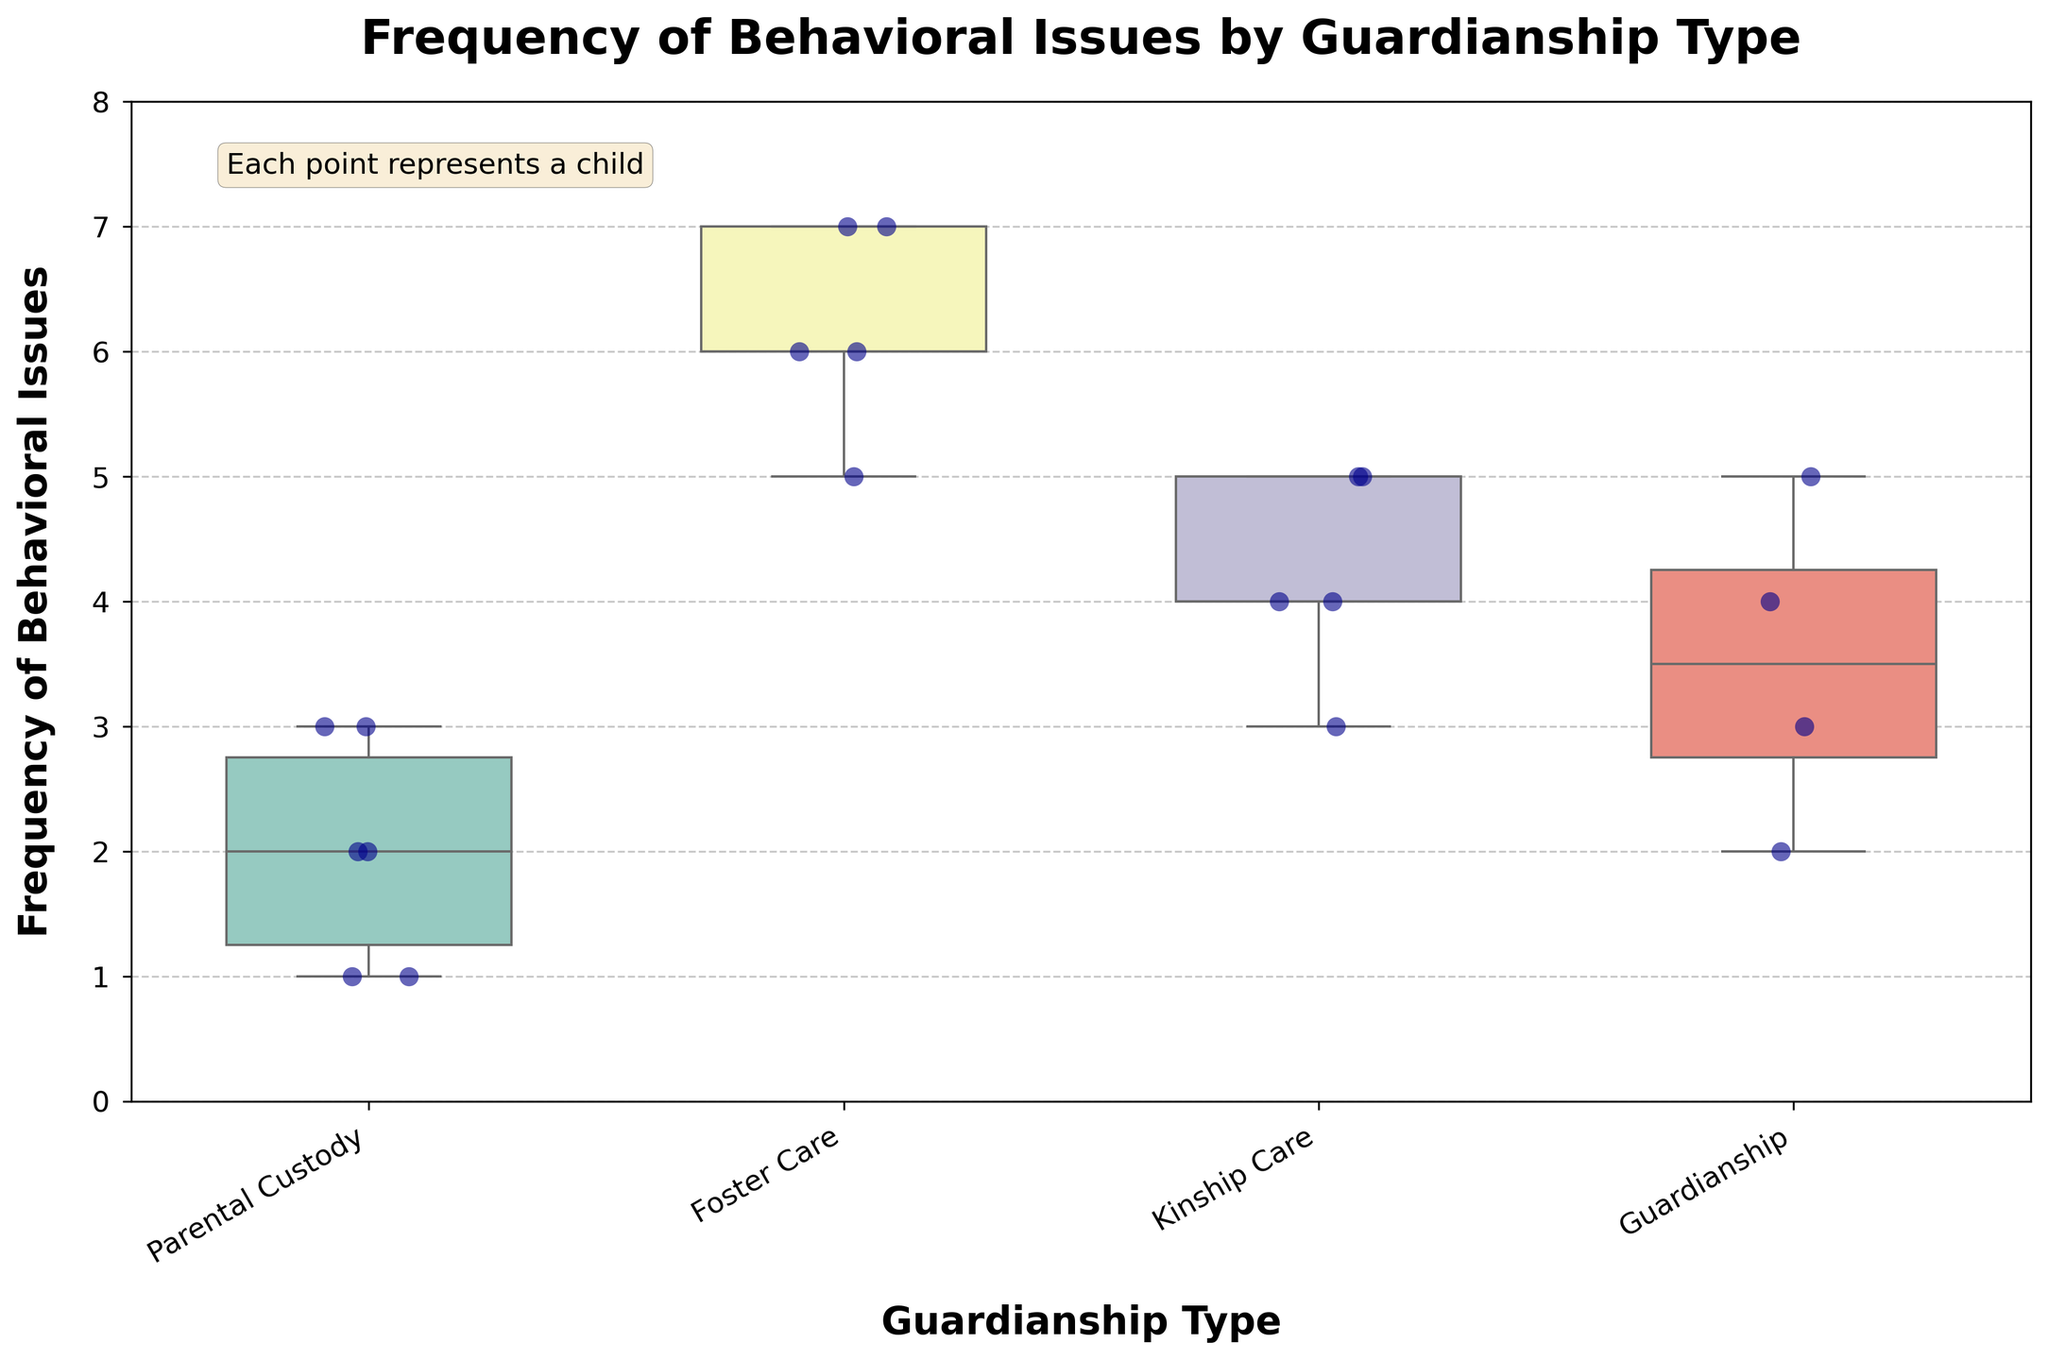What's the title of the plot? The title is displayed at the top of the plot, providing a descriptive overview of the content being represented. In this case, the title of the plot is 'Frequency of Behavioral Issues by Guardianship Type'.
Answer: Frequency of Behavioral Issues by Guardianship Type What is the guardianship type with the highest median frequency of behavioral issues? To find the guardianship type with the highest median, look at the central line in each box plot. The box plot for 'Foster Care' has the highest median line.
Answer: Foster Care What are the lowest and highest frequencies of behavioral issues among children under parental custody? To find the range, look at the whiskers of the box plot corresponding to 'Parental Custody'. The lowest point is 1, and the highest point is 3.
Answer: 1 and 3 Which guardianship types have any outliers represented by scatter points that are far from the box plot? Inspect the scatter points and see if any point is significantly away from the box plot's whiskers. 'Foster Care' has some points far above.
Answer: Foster Care How many children are in kinship care according to the scatter points? Count the number of scatter points above the 'Kinship Care' label. There are 4 scatter points present.
Answer: 4 Which guardianship type has the widest range of behavioral issues frequency? The range can be determined by measuring the distance between the lower and upper whiskers of each box plot. ‘Foster Care’ has the widest range.
Answer: Foster Care What is the second highest median frequency of behavioral issues across guardianship types? The median is indicated by the central line inside the boxes. After 'Foster Care', the next highest median is for 'Guardianship'.
Answer: Guardianship In which guardianship type does the most frequent behavior issue frequency appear to cluster around a single value? Observe where most of the scatter points gather. For 'Parental Custody', many points cluster around the frequencies of 1 and 2, indicating tightly grouped data.
Answer: Parental Custody How does the variability in frequencies for children under guardianship compare to those in foster care? Compare the spread of whiskers and the interquartile ranges in the box plot for 'Guardianship' versus 'Foster Care'. 'Foster Care' shows more variability with a wider range.
Answer: Foster Care has more variability 